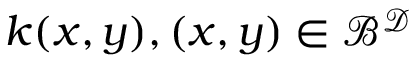<formula> <loc_0><loc_0><loc_500><loc_500>k ( x , y ) , ( x , y ) \in \mathcal { B } ^ { \mathcal { D } }</formula> 